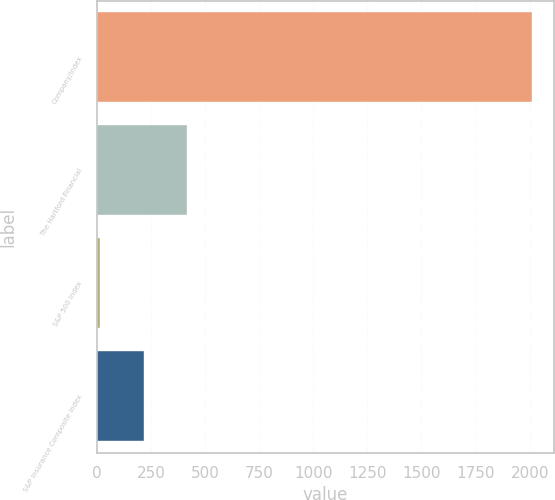Convert chart to OTSL. <chart><loc_0><loc_0><loc_500><loc_500><bar_chart><fcel>Company/Index<fcel>The Hartford Financial<fcel>S&P 500 Index<fcel>S&P Insurance Composite Index<nl><fcel>2012<fcel>415.2<fcel>16<fcel>215.6<nl></chart> 